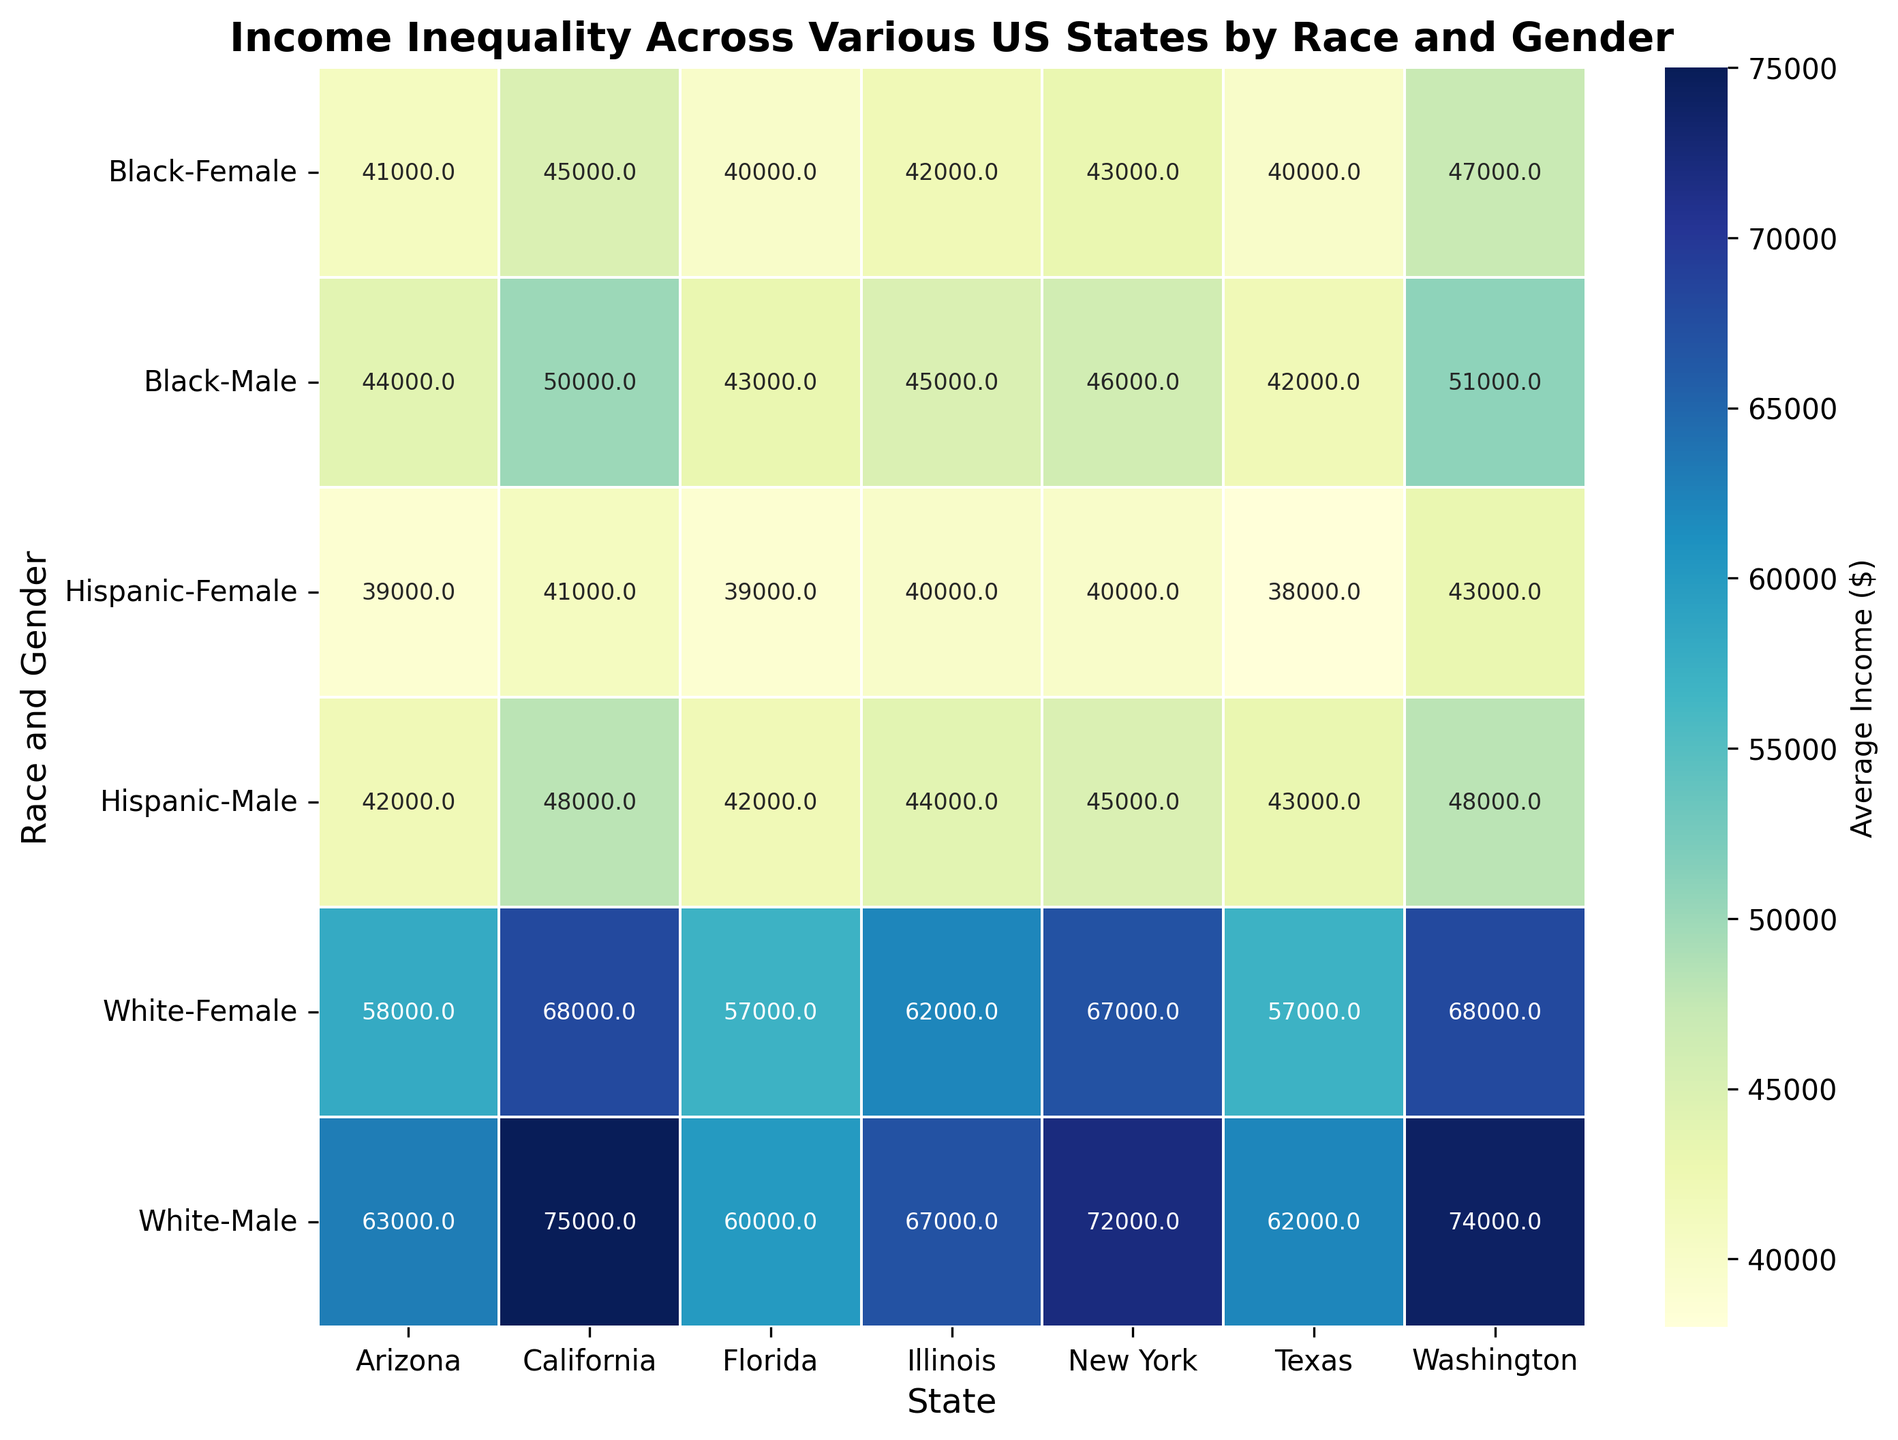What is the average income for Black females in New York and Arizona combined? First, identify the average income for Black females in New York ($43,000) and Arizona ($41,000). Then sum these amounts: 43,000 + 41,000 = 84,000. Finally, divide by 2 to get the average: 84,000 / 2 = 42,000
Answer: $42,000 Which state has the highest average income for White males? Look for the highest number in the row labeled 'White, Male' across all states. Washington has the highest at $74,000
Answer: Washington In California, is the income disparity larger between Black males and White males or between Hispanic females and White males? Calculate the differences: White males vs. Black males: $75,000 - $50,000 = $25,000. White males vs. Hispanic females: $75,000 - $41,000 = $34,000. The larger disparity is between White males and Hispanic females
Answer: Hispanic females and White males Compare the income of Hispanic females across all the states. Which state has the highest and lowest income for them? Review the income values in the row for 'Hispanic, Female'. The highest is in California ($41,000), and the lowest is in Texas and Florida ($38,000)
Answer: Highest: California, Lowest: Texas and Florida Considering only the data for White females and Black males, which gender and race combination tends to have higher income across the states? Compare the income values across these two groups for each state. In all states except Arizona, White females have higher average incomes than Black males
Answer: White females What is the general trend in income between males and females within the same race across different states? The heatmap shows that males generally have higher incomes compared to females within the same race across most states
Answer: Males have higher incomes Calculate the overall average income across all gender and race categories for New York. Sum the values for New York: $72,000 + $67,000 + $46,000 + $43,000 + $45,000 + $40,000 = $313,000. Then divide by the number of groups (6): 313,000 / 6 ≈ $52,167
Answer: $52,167 Which state shows the smallest income discrepancy between White males and Black females? Calculate the differences for each state: California: $75,000 - $45,000 = $30,000; Texas: $62,000 - $40,000 = $22,000; New York: $72,000 - $43,000 = $29,000; Florida: $60,000 - $40,000 = $20,000; Illinois: $67,000 - $42,000 = $25,000; Arizona: $63,000 - $41,000 = $22,000; Washington: $74,000 - $47,000 = $27,000. The smallest discrepancy is in Florida ($20,000)
Answer: Florida Between Black males and Hispanic males, which group has a higher average income in more states? Compare the average incomes for Black males and Hispanic males in each state: California: Black males (50,000) > Hispanic males (48,000), Texas: Black males (42,000) < Hispanic males (43,000), New York: Black males (46,000) > Hispanic males (45,000), Florida: Black males (43,000) > Hispanic males (42,000), Illinois: Black males (45,000) > Hispanic males (44,000), Arizona: Black males (44,000) > Hispanic males (42,000), Washington: Black males (51,000) > Hispanic males (48,000). Black males have higher average incomes in 6 states compared to Hispanic males
Answer: Black males 